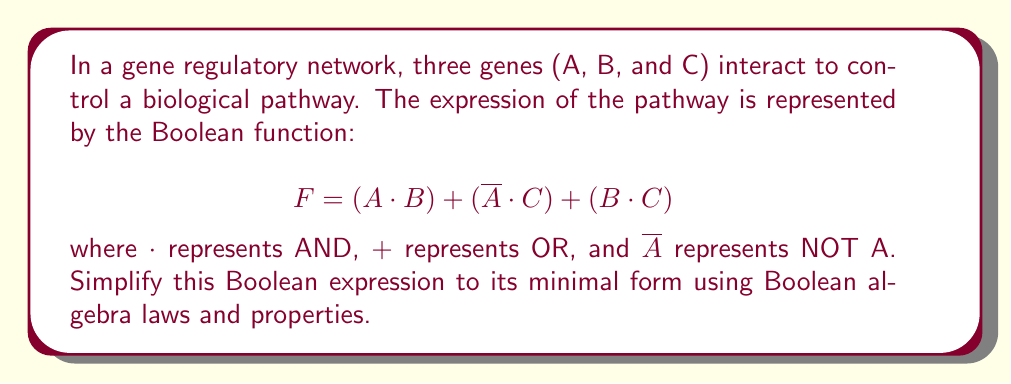Can you answer this question? Let's simplify the expression step by step using Boolean algebra laws:

1) First, we can apply the distributive law to expand the last term:
   $$ F = (A \cdot B) + (\overline{A} \cdot C) + (B \cdot C) $$
   $$ = (A \cdot B) + (\overline{A} \cdot C) + (B \cdot C \cdot 1) $$
   $$ = (A \cdot B) + (\overline{A} \cdot C) + (B \cdot C \cdot (A + \overline{A})) $$

2) Distribute $B \cdot C$ over $(A + \overline{A})$:
   $$ = (A \cdot B) + (\overline{A} \cdot C) + (A \cdot B \cdot C) + (\overline{A} \cdot B \cdot C) $$

3) Group terms with A and $\overline{A}$:
   $$ = (A \cdot B) + (A \cdot B \cdot C) + (\overline{A} \cdot C) + (\overline{A} \cdot B \cdot C) $$
   $$ = [A \cdot (B + (B \cdot C))] + [\overline{A} \cdot (C + (B \cdot C))] $$

4) Simplify the terms in parentheses:
   $B + (B \cdot C) = B$ (absorption law)
   $C + (B \cdot C) = C$ (absorption law)

5) Substituting these simplifications:
   $$ = (A \cdot B) + (\overline{A} \cdot C) $$

This is the minimal form of the Boolean expression.
Answer: $$ F = (A \cdot B) + (\overline{A} \cdot C) $$ 